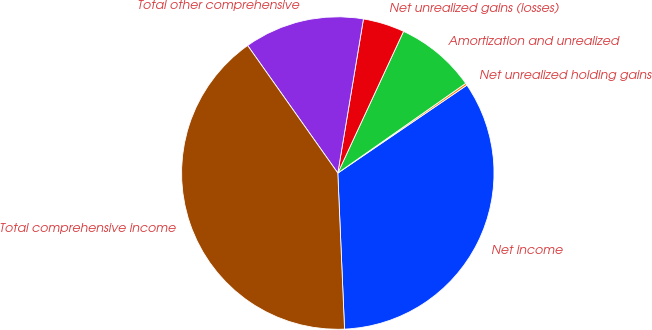Convert chart. <chart><loc_0><loc_0><loc_500><loc_500><pie_chart><fcel>Net income<fcel>Net unrealized holding gains<fcel>Amortization and unrealized<fcel>Net unrealized gains (losses)<fcel>Total other comprehensive<fcel>Total comprehensive income<nl><fcel>33.83%<fcel>0.22%<fcel>8.35%<fcel>4.29%<fcel>12.42%<fcel>40.89%<nl></chart> 